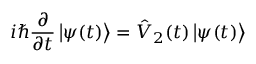<formula> <loc_0><loc_0><loc_500><loc_500>i \hslash \frac { \partial } { \partial t } \left | \psi ( t ) \right \rangle = \hat { V } _ { 2 } ( t ) \left | \psi ( t ) \right \rangle</formula> 